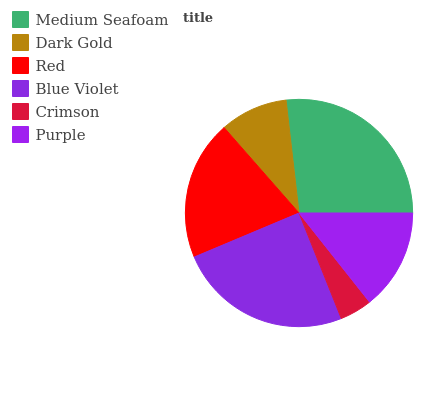Is Crimson the minimum?
Answer yes or no. Yes. Is Medium Seafoam the maximum?
Answer yes or no. Yes. Is Dark Gold the minimum?
Answer yes or no. No. Is Dark Gold the maximum?
Answer yes or no. No. Is Medium Seafoam greater than Dark Gold?
Answer yes or no. Yes. Is Dark Gold less than Medium Seafoam?
Answer yes or no. Yes. Is Dark Gold greater than Medium Seafoam?
Answer yes or no. No. Is Medium Seafoam less than Dark Gold?
Answer yes or no. No. Is Red the high median?
Answer yes or no. Yes. Is Purple the low median?
Answer yes or no. Yes. Is Blue Violet the high median?
Answer yes or no. No. Is Dark Gold the low median?
Answer yes or no. No. 